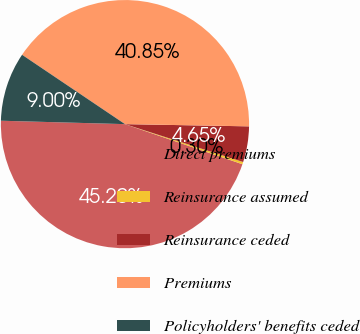Convert chart to OTSL. <chart><loc_0><loc_0><loc_500><loc_500><pie_chart><fcel>Direct premiums<fcel>Reinsurance assumed<fcel>Reinsurance ceded<fcel>Premiums<fcel>Policyholders' benefits ceded<nl><fcel>45.2%<fcel>0.3%<fcel>4.65%<fcel>40.85%<fcel>9.0%<nl></chart> 